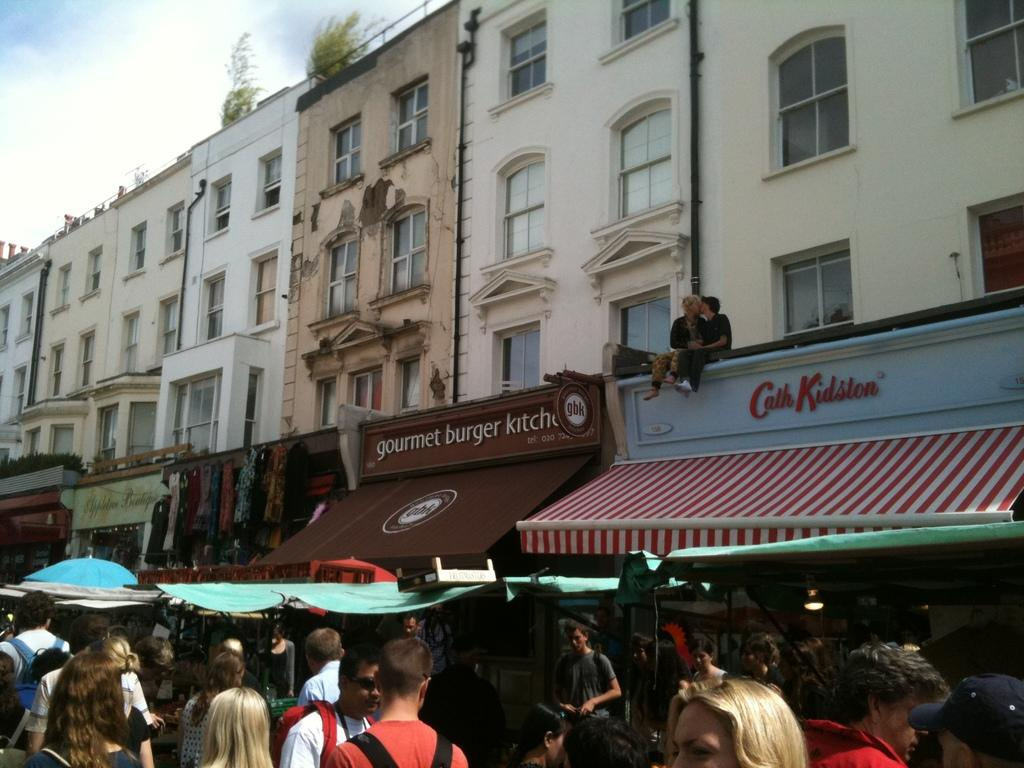What is happening on the road in the image? There is a crowd on the road in the image. What structures can be seen in the image? There are tents and shops in the image. What can be seen in the background of the image? There are buildings, plants, and the sky visible in the background of the image. What type of knee injury can be seen in the image? There is no knee injury present in the image. What sense is being stimulated by the image? The image is visual, so the sense of sight is being stimulated. 